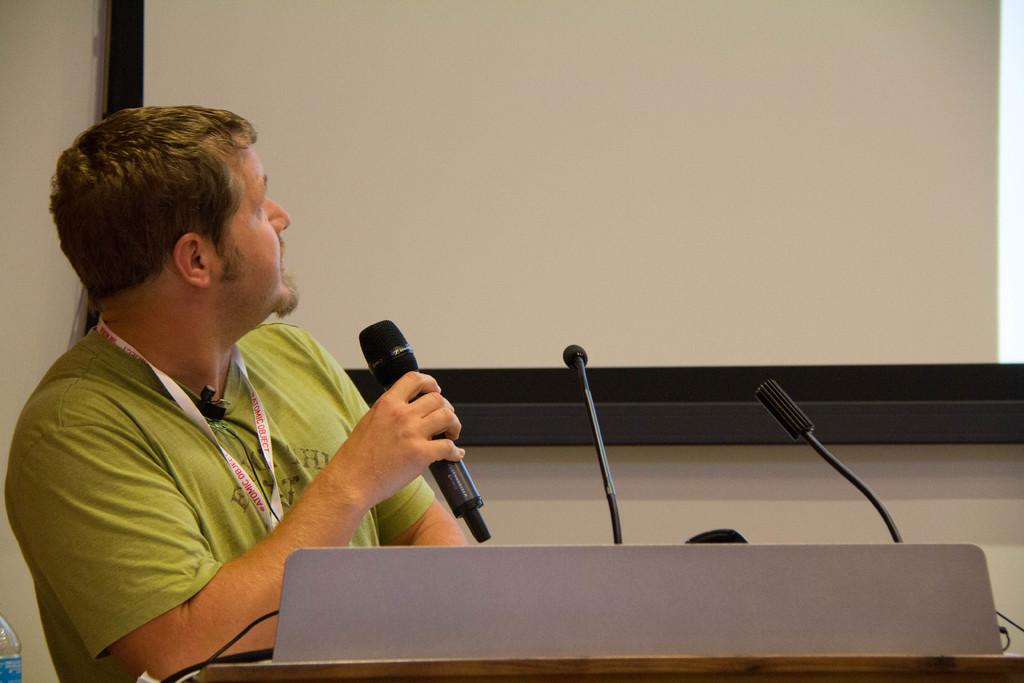Who is present in the image? There is a man in the image. What is the man holding in the image? The man is holding a microphone. What other objects can be seen in the image? There is a bottle, a wall, and a screen in the image. What type of sheet is covering the earth in the image? There is no sheet or earth present in the image. What is the man drinking from the glass in the image? There is no glass present in the image; the man is holding a microphone. 